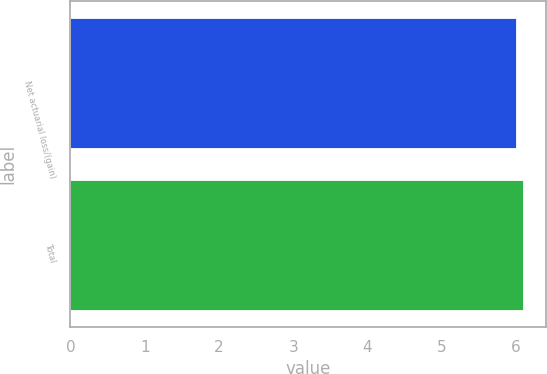<chart> <loc_0><loc_0><loc_500><loc_500><bar_chart><fcel>Net actuarial loss/(gain)<fcel>Total<nl><fcel>6<fcel>6.1<nl></chart> 